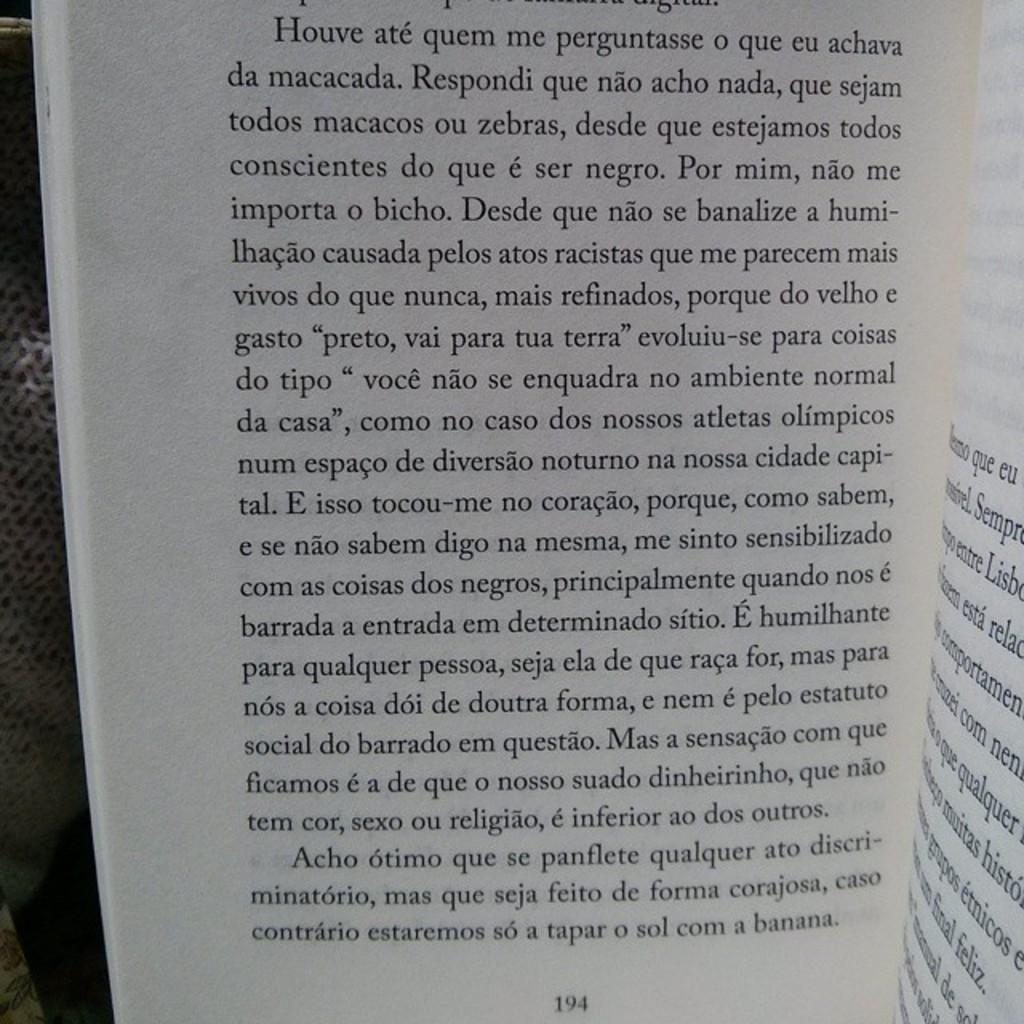<image>
Create a compact narrative representing the image presented. An open book written in a foreign language opened to page 194. 